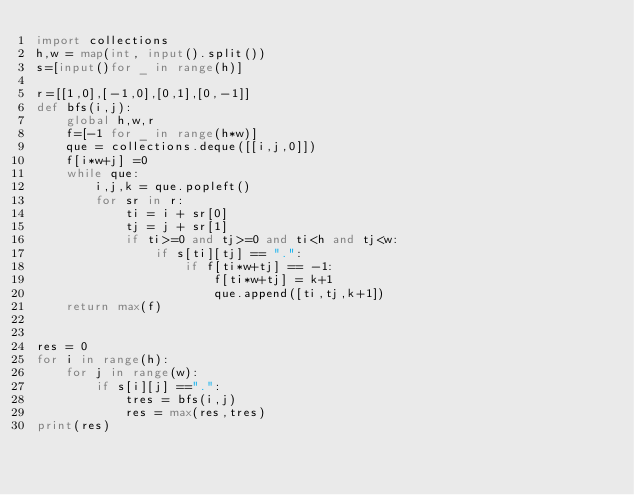<code> <loc_0><loc_0><loc_500><loc_500><_Python_>import collections
h,w = map(int, input().split())
s=[input()for _ in range(h)]

r=[[1,0],[-1,0],[0,1],[0,-1]]
def bfs(i,j):
    global h,w,r
    f=[-1 for _ in range(h*w)]
    que = collections.deque([[i,j,0]])
    f[i*w+j] =0
    while que:
        i,j,k = que.popleft()
        for sr in r:
            ti = i + sr[0]
            tj = j + sr[1]
            if ti>=0 and tj>=0 and ti<h and tj<w:
                if s[ti][tj] == ".":
                    if f[ti*w+tj] == -1:
                        f[ti*w+tj] = k+1
                        que.append([ti,tj,k+1])
    return max(f)


res = 0
for i in range(h):
    for j in range(w):
        if s[i][j] ==".":
            tres = bfs(i,j)
            res = max(res,tres)
print(res)
</code> 